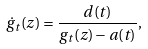Convert formula to latex. <formula><loc_0><loc_0><loc_500><loc_500>\dot { g } _ { t } ( z ) = \frac { d ( t ) } { g _ { t } ( z ) - a ( t ) } ,</formula> 